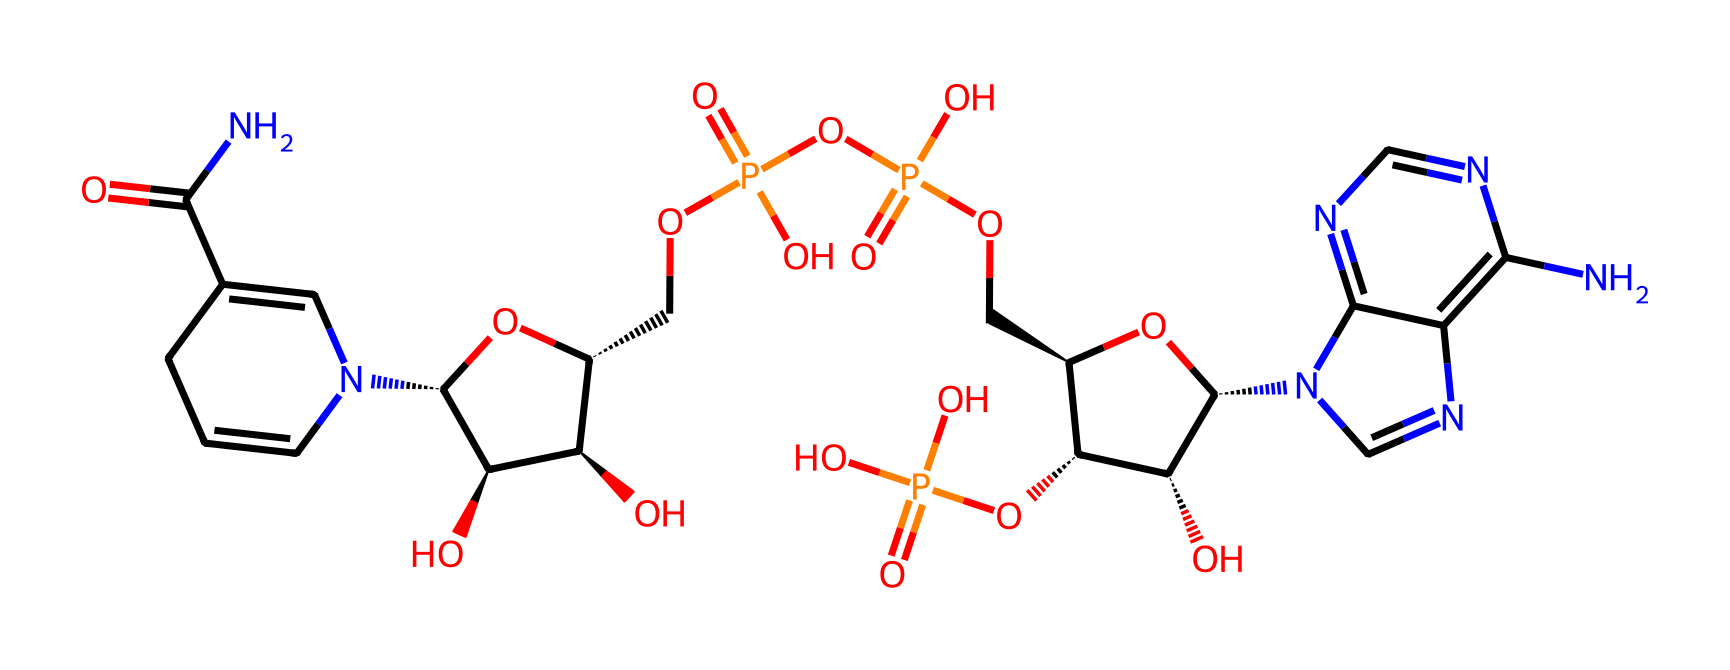What is the molecular formula of NADPH? To determine the molecular formula from the SMILES representation, identify the main components: nitrogen, carbon, oxygen, and phosphorus atoms. Counting each atom as you decode the structure will reveal the molecular formula, which for NADPH is C17H32N7O17P3.
Answer: C17H32N7O17P3 How many nitrogen atoms are present in this molecule? By analyzing the SMILES notation, identify each instance of the nitrogen (N) in the structure. Count the total occurrences, which show that there are 7 nitrogen atoms within the molecule.
Answer: 7 What is the role of NADPH in photosynthesis? NADPH serves as an electron donor in the light-independent reactions (Calvin cycle) of photosynthesis, facilitating the conversion of carbon dioxide to glucose. This takes place as it donates electrons, reducing compounds during the process.
Answer: electron donor What type of compound does NADPH represent? Given the structure and its content, NADPH is classified as a nucleotide, more specifically a nucleotide coenzyme, due to its involvement in essential biological reactions including photosynthesis.
Answer: nucleotide How many phosphate groups are found in NADPH? Analyze the structure for phosphate (P) components, which can be identified as OP(=O)(O). Noting each occurrence reveals there are 3 phosphate groups present in NADPH.
Answer: 3 What function do the ribose sugars serve in NADPH? The ribose sugars are integral to the overall structure of NADPH by providing a backbone that links the nucleotide components and is essential for proper function in biological processes such as the transfer of electrons.
Answer: backbone in nucleotide structure Which part of NADPH is responsible for its ability to donate electrons? The key part of NADPH responsible for its electron-donating ability is the reduced nicotinamide (the nitrogen-containing ring) that accepts and donates electrons via reversible reactions in biochemical pathways.
Answer: reduced nicotinamide 